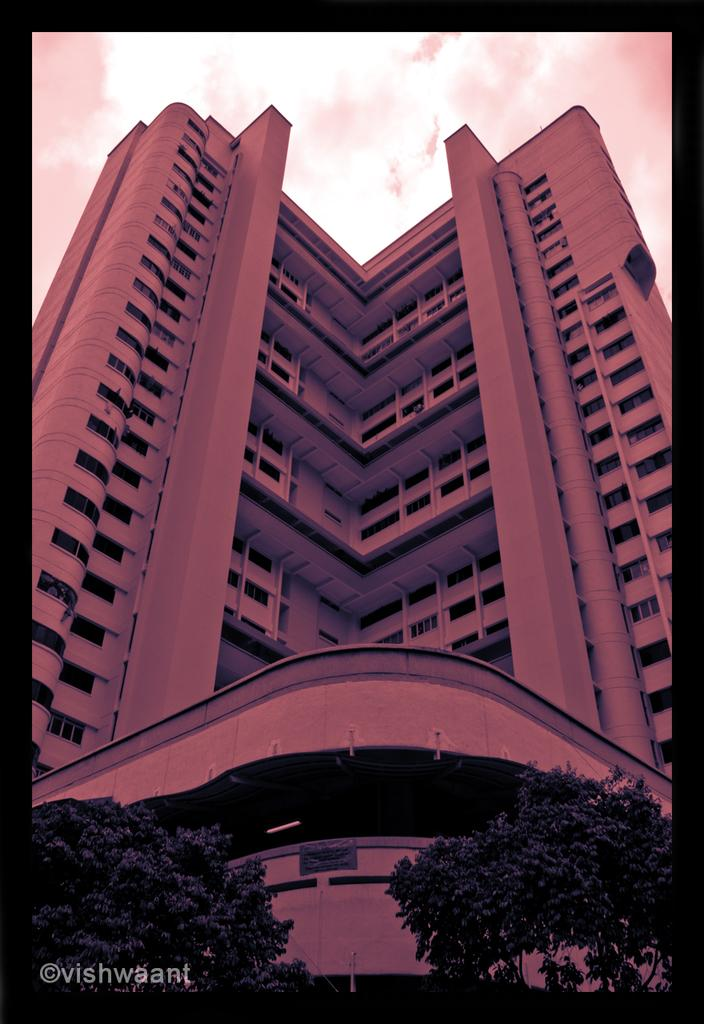What type of structure is visible in the image? There is a building with windows in the image. What other natural elements can be seen in the image? There are trees with branches and leaves in the image. What part of the environment is visible in the image? The sky is visible in the image. What type of bike is parked in front of the building in the image? There is no bike present in the image; it only features a building, trees, and the sky. In what year was the image taken? The provided facts do not include information about the year the image was taken. 